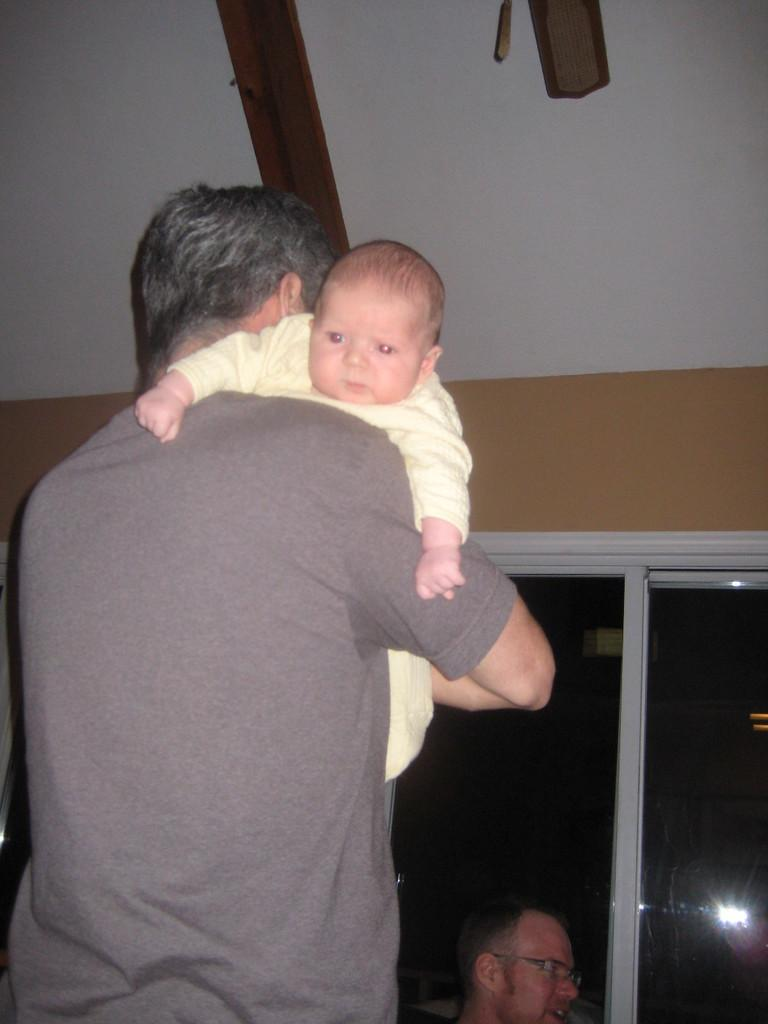What is the person holding in the image? The person is holding a baby in the image. Can you describe the position of the other person in relation to the person holding the baby? There is another person in front of the person holding the baby. What architectural feature can be seen in the image? There is a window in the middle of a wall in the image. What type of advertisement can be seen on the baby's clothing in the image? There is no advertisement visible on the baby's clothing in the image. What color is the tin used to hold the baby in the image? There is no tin present in the image; the baby is being held by a person. 